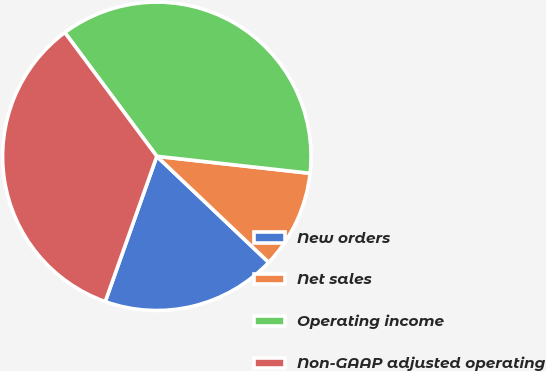Convert chart to OTSL. <chart><loc_0><loc_0><loc_500><loc_500><pie_chart><fcel>New orders<fcel>Net sales<fcel>Operating income<fcel>Non-GAAP adjusted operating<nl><fcel>18.35%<fcel>10.32%<fcel>36.93%<fcel>34.4%<nl></chart> 